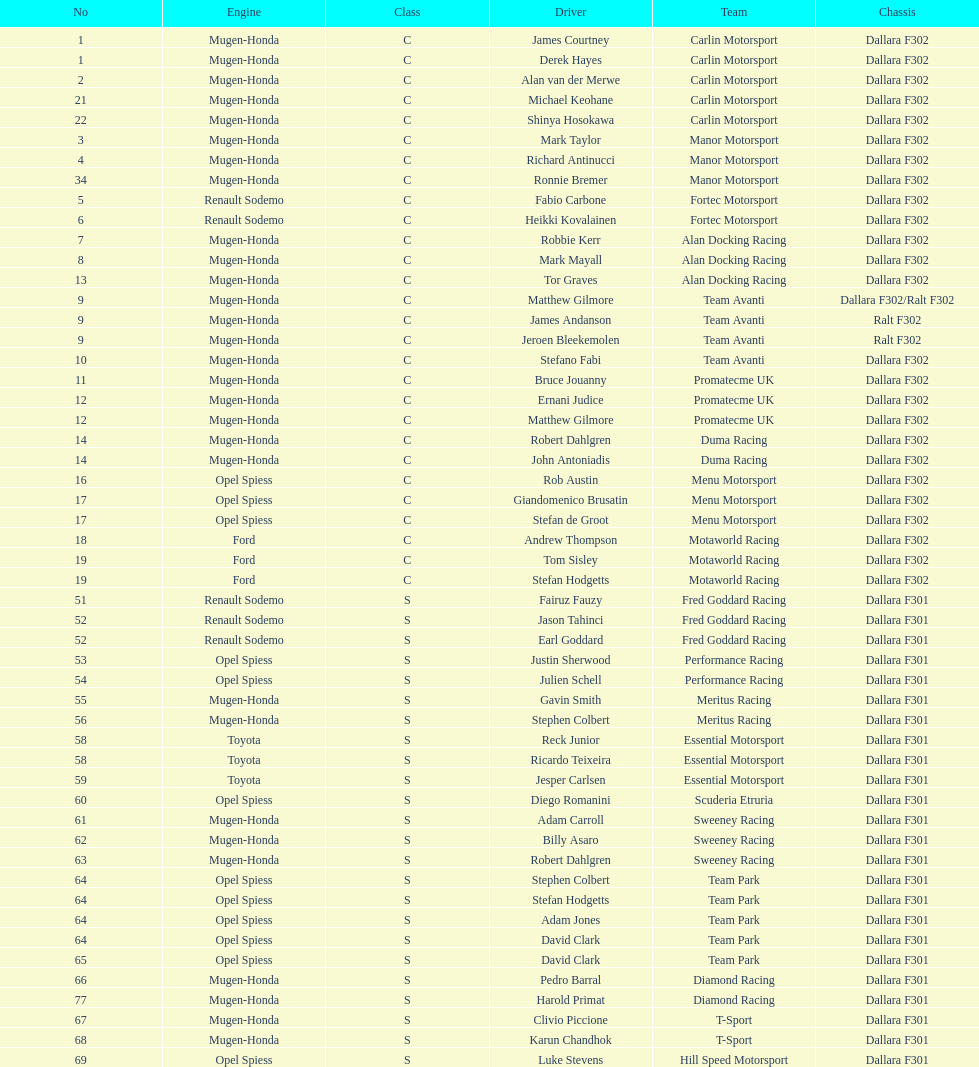What is the average number of teams that had a mugen-honda engine? 24. 